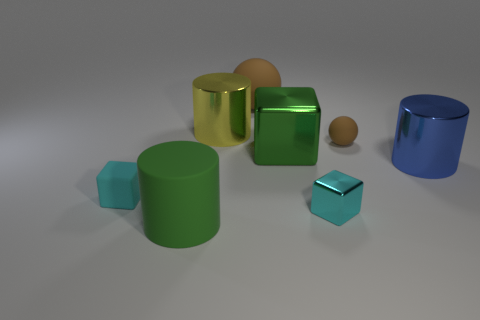Add 1 blue cylinders. How many objects exist? 9 Subtract all cylinders. How many objects are left? 5 Subtract 0 cyan spheres. How many objects are left? 8 Subtract all brown matte things. Subtract all brown rubber objects. How many objects are left? 4 Add 6 green shiny things. How many green shiny things are left? 7 Add 8 small balls. How many small balls exist? 9 